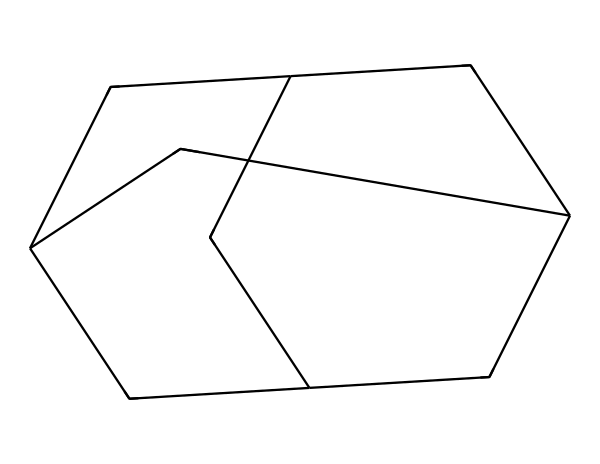What is the total number of carbon atoms in adamantane? By analyzing the given SMILES representation, we can count the number of carbon atoms represented. In the structure, each "C" stands for a carbon atom. Counting the occurrences, we find that there are 10 carbon atoms present in the molecular structure.
Answer: 10 How many hydrogen atoms are bonded to the carbon atoms in adamantane? In adamantane, each carbon atom typically bonds with enough hydrogen atoms to fulfill its tetravalency (4 bonds). Given that there are 10 carbon atoms, the formula for adamantane is C10H16, which indicates there are 16 hydrogen atoms.
Answer: 16 What type of chemical structure does adamantane represent? Adamantane has a three-dimensional, cage-like structure, which is characteristic of cage compounds. This structure allows for a unique arrangement of its carbon atoms, contributing to its stability.
Answer: cage-like What is the molecular formula of adamantane? By combining the total count of carbon and hydrogen atoms, we derive the molecular formula. Thus, the formula representing adamantane with 10 carbon and 16 hydrogen atoms becomes C10H16.
Answer: C10H16 Is adamantane a saturated or unsaturated hydrocarbon? In adamantane, all carbon-carbon bonds are single bonds, which means it has the maximum number of hydrogen atoms for its carbon skeleton, indicating that it is a saturated hydrocarbon.
Answer: saturated How does the three-dimensional structure of adamantane affect its medicinal properties? The cage-like three-dimensional structure of adamantane enables the compound to interact with biological targets in a specific way. This unique shape can influence how adamantane fits into the binding sites of certain enzymes and receptors, potentially affecting its efficacy in pharmaceuticals.
Answer: influences interaction What is a common application of adamantane in pharmaceuticals? Adamantane is frequently used as a core structure in antiviral medications, particularly for the treatment of influenza, where it has shown effectiveness in disrupting viral function.
Answer: antiviral medications 